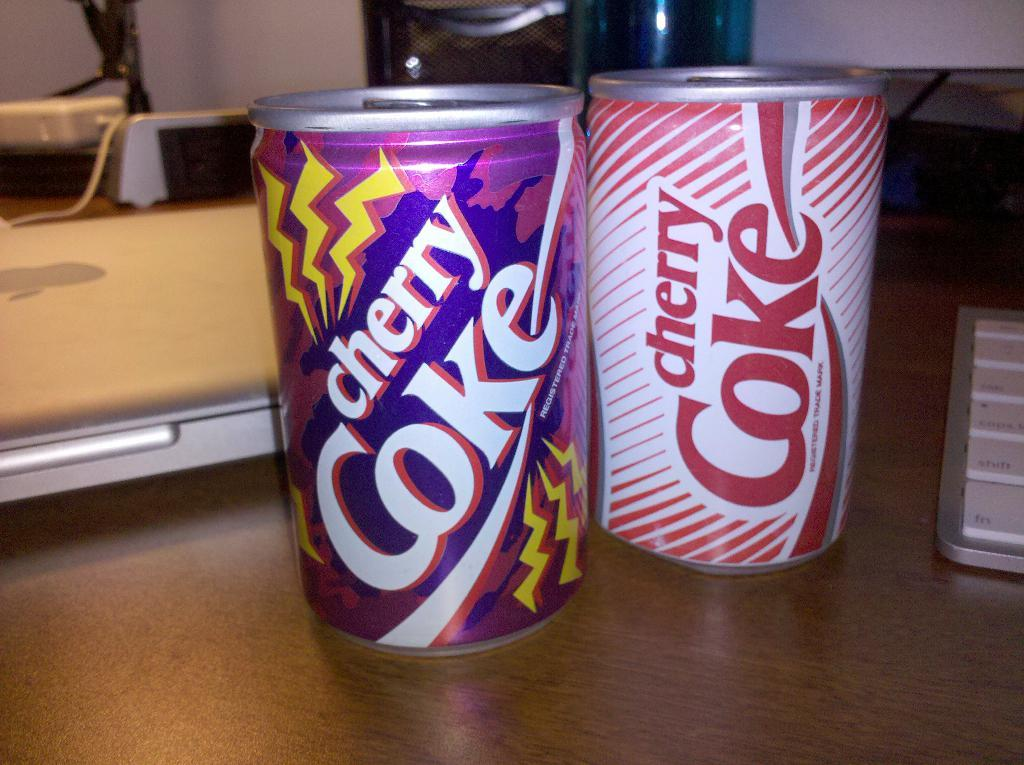Provide a one-sentence caption for the provided image. Two cans of cherry Coke sit next to each other on a wooden desk. 